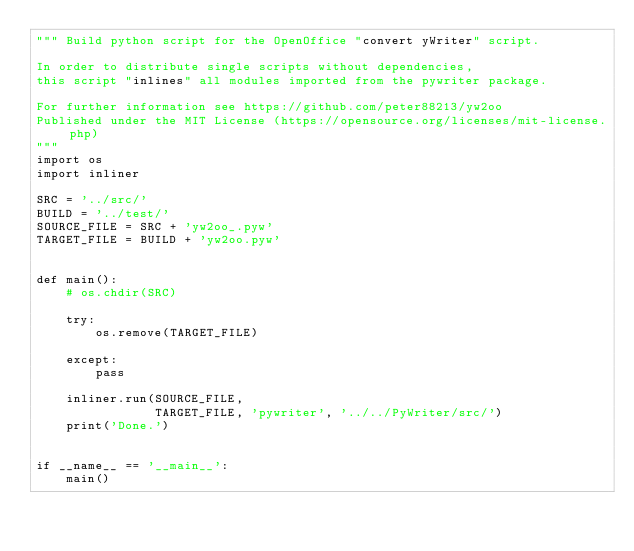<code> <loc_0><loc_0><loc_500><loc_500><_Python_>""" Build python script for the OpenOffice "convert yWriter" script.
        
In order to distribute single scripts without dependencies, 
this script "inlines" all modules imported from the pywriter package.

For further information see https://github.com/peter88213/yw2oo
Published under the MIT License (https://opensource.org/licenses/mit-license.php)
"""
import os
import inliner

SRC = '../src/'
BUILD = '../test/'
SOURCE_FILE = SRC + 'yw2oo_.pyw'
TARGET_FILE = BUILD + 'yw2oo.pyw'


def main():
    # os.chdir(SRC)

    try:
        os.remove(TARGET_FILE)

    except:
        pass

    inliner.run(SOURCE_FILE,
                TARGET_FILE, 'pywriter', '../../PyWriter/src/')
    print('Done.')


if __name__ == '__main__':
    main()
</code> 